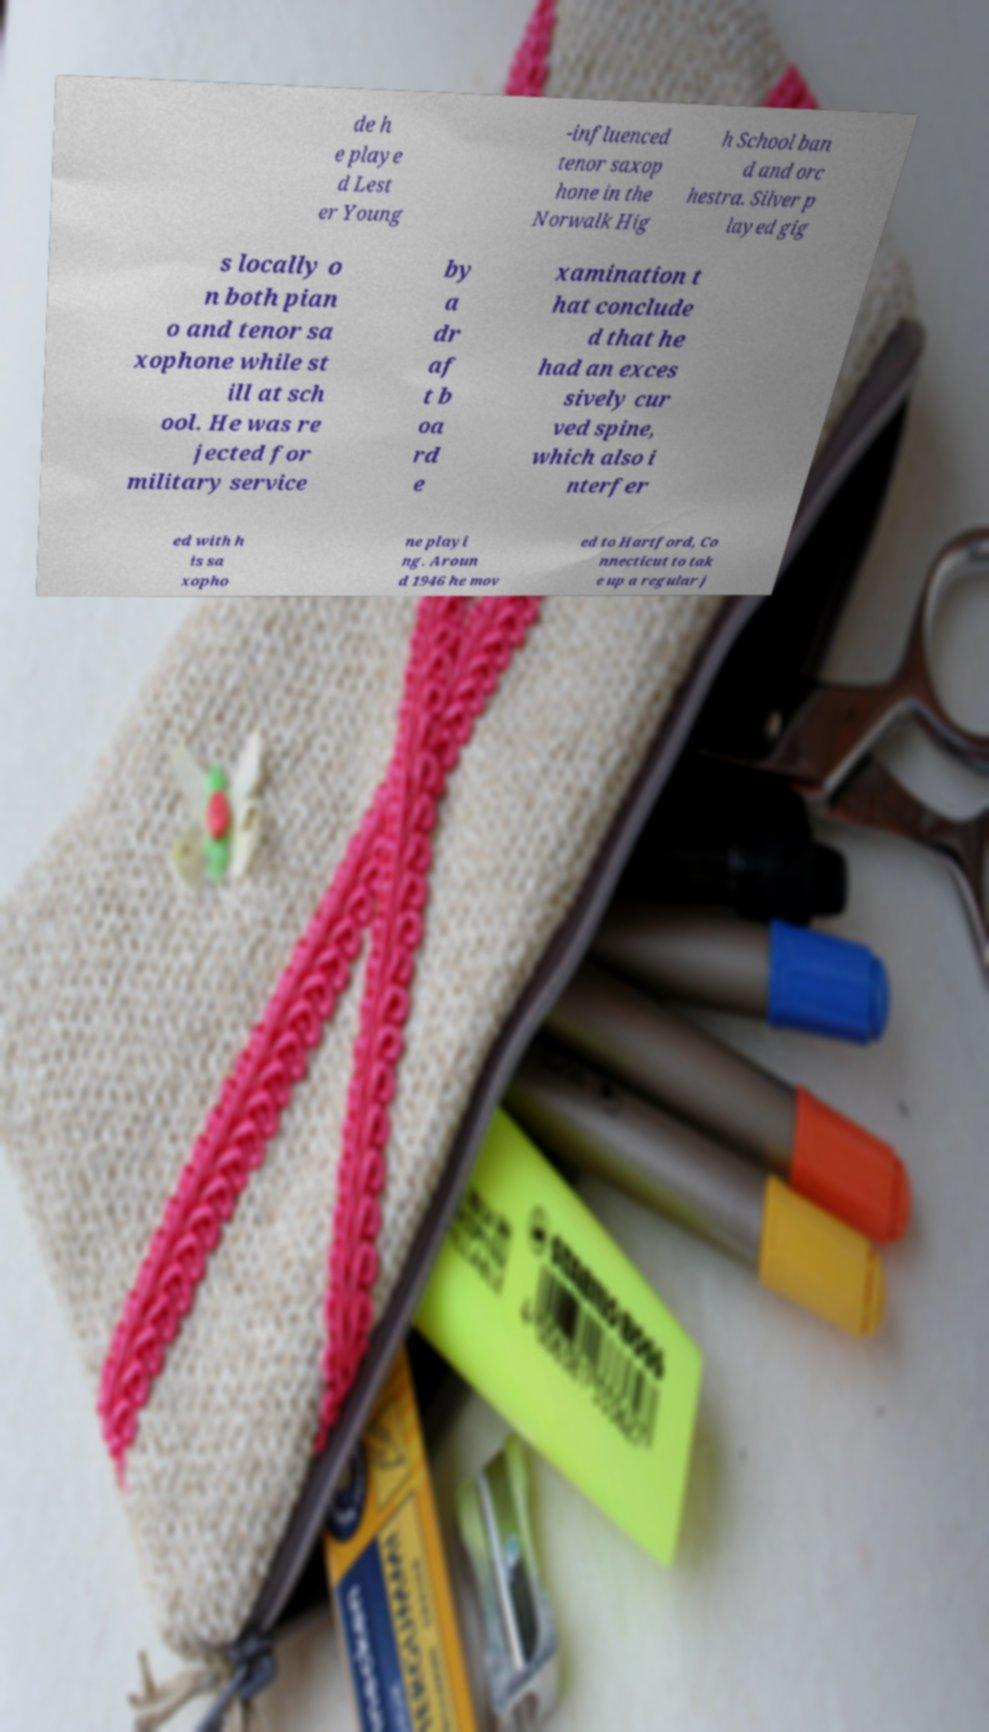Please identify and transcribe the text found in this image. de h e playe d Lest er Young -influenced tenor saxop hone in the Norwalk Hig h School ban d and orc hestra. Silver p layed gig s locally o n both pian o and tenor sa xophone while st ill at sch ool. He was re jected for military service by a dr af t b oa rd e xamination t hat conclude d that he had an exces sively cur ved spine, which also i nterfer ed with h is sa xopho ne playi ng. Aroun d 1946 he mov ed to Hartford, Co nnecticut to tak e up a regular j 